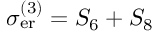<formula> <loc_0><loc_0><loc_500><loc_500>\sigma _ { e r } ^ { ( 3 ) } = S _ { 6 } + S _ { 8 }</formula> 